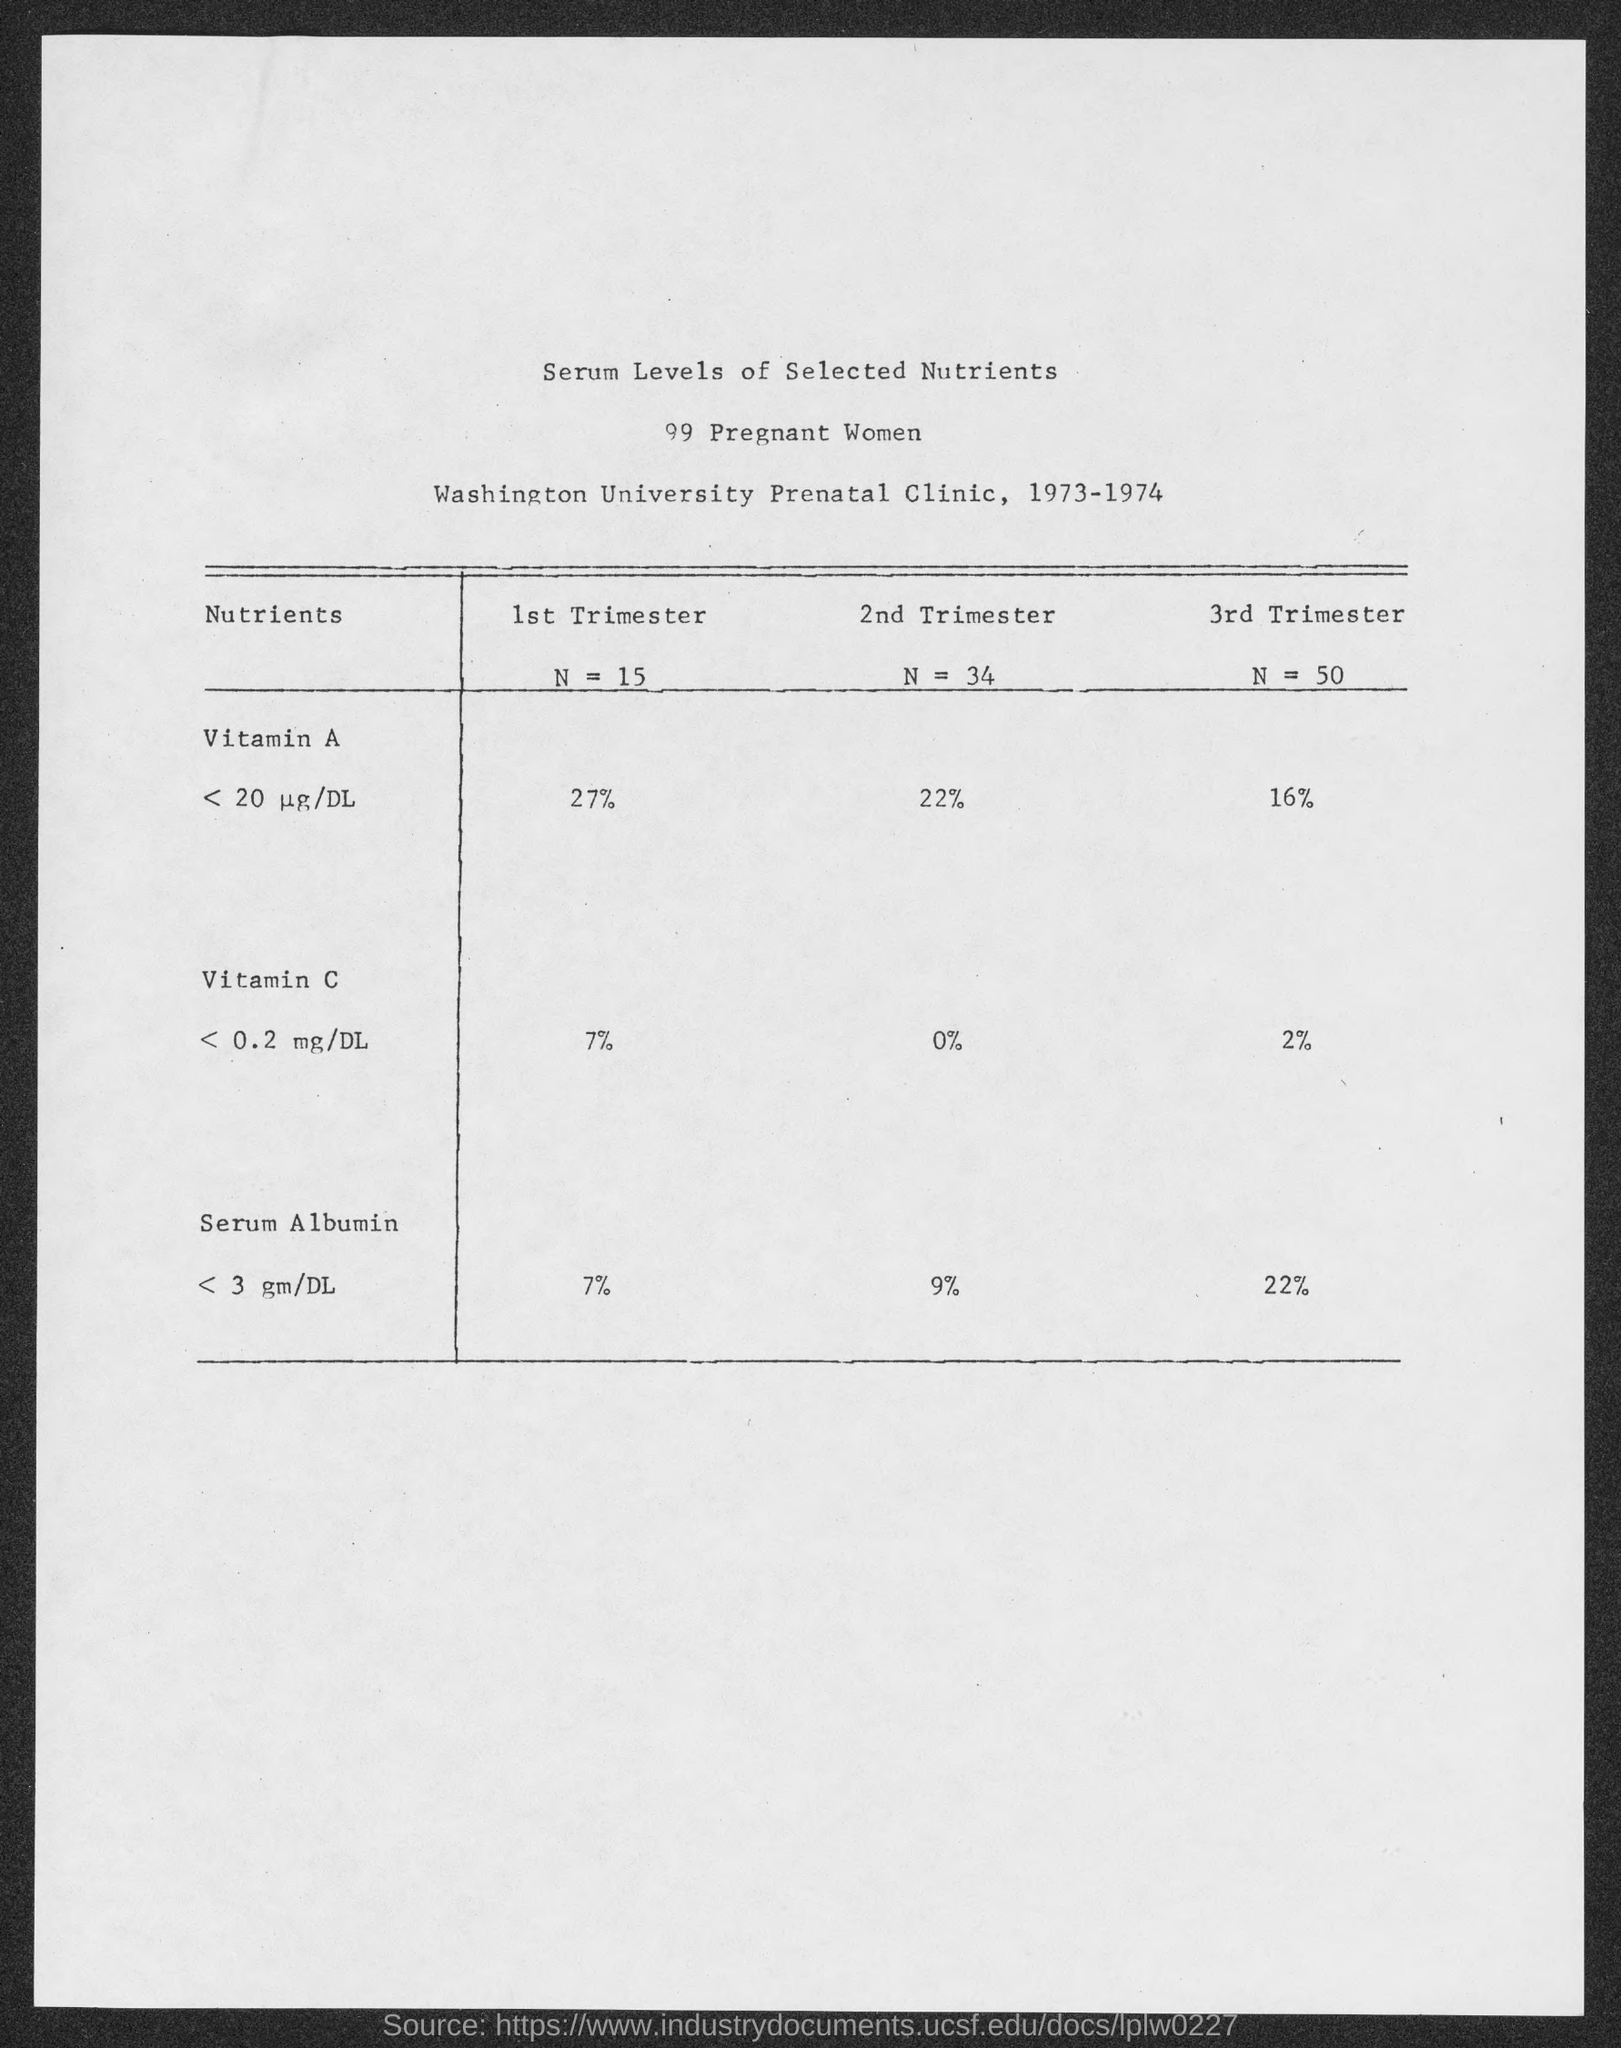What is the value of N in the 1st Trimester?
Your answer should be compact. 15. What is the value of Vitamin A in the 2nd Trimester?
Provide a short and direct response. 22%. What is the value of Serum Albumin in 3rd Trimester?
Provide a succinct answer. 22%. What is the number of Pregnant Women?
Give a very brief answer. 99 pregnant women. What is the range of years mentioned in the document ?
Your answer should be compact. 1973-1974. 